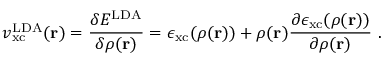Convert formula to latex. <formula><loc_0><loc_0><loc_500><loc_500>v _ { x c } ^ { L D A } ( r ) = { \frac { \delta E ^ { L D A } } { \delta \rho ( r ) } } = \epsilon _ { x c } ( \rho ( r ) ) + \rho ( r ) { \frac { \partial \epsilon _ { x c } ( \rho ( r ) ) } { \partial \rho ( r ) } } \ .</formula> 